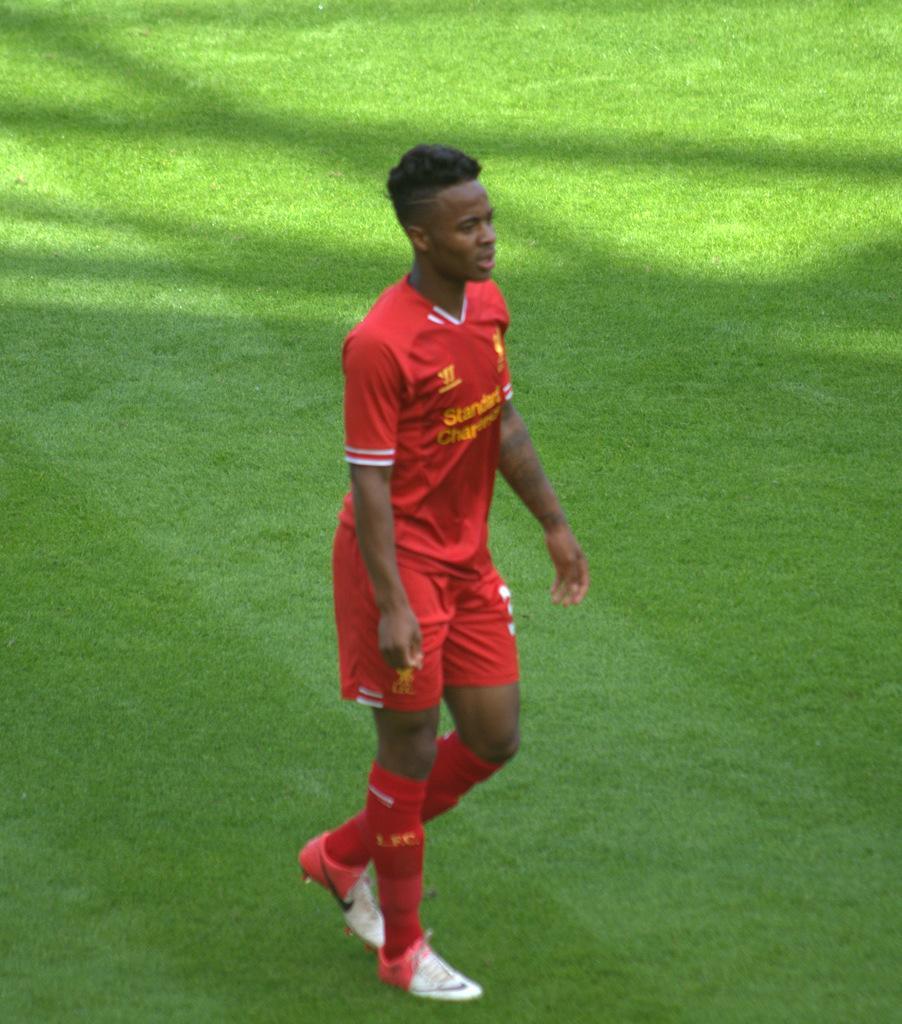How would you summarize this image in a sentence or two? In this image I can see a man is standing on the ground. The man is wearing red color clothes and footwears. Here I can see the grass. 